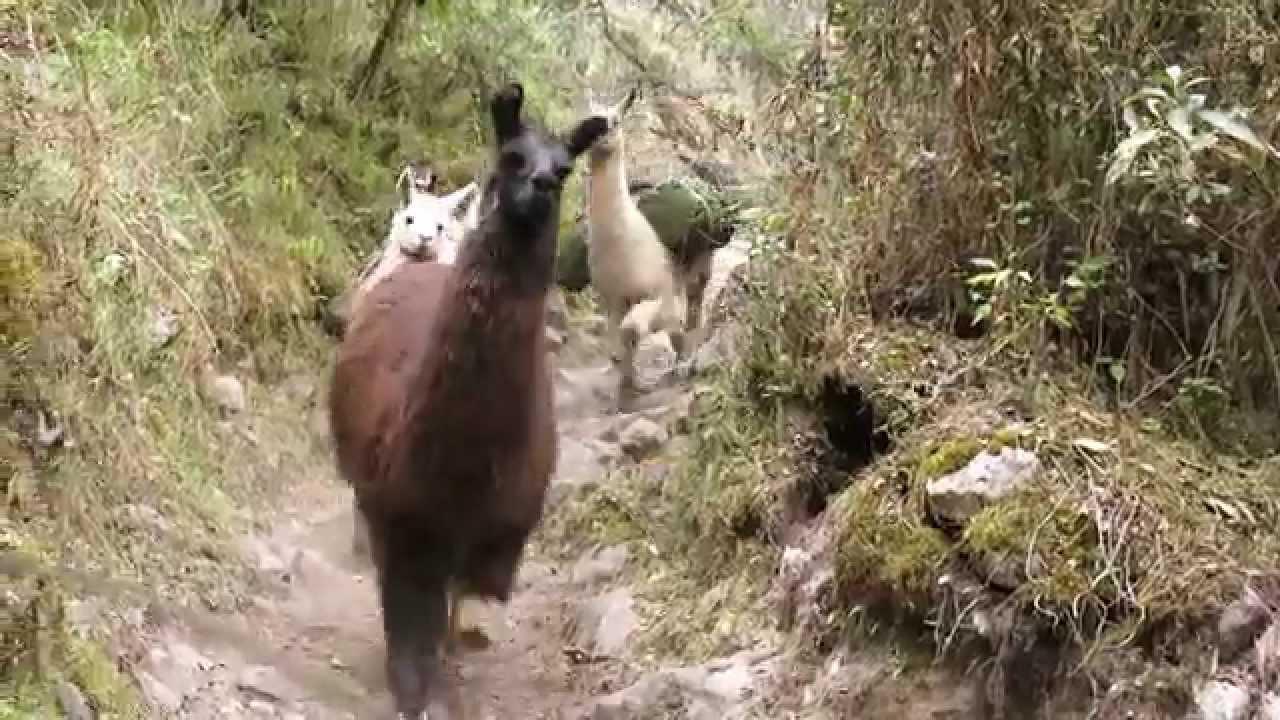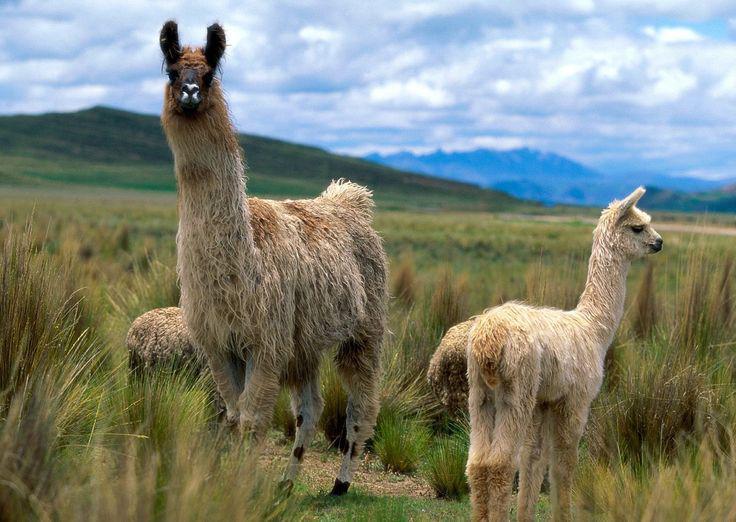The first image is the image on the left, the second image is the image on the right. Assess this claim about the two images: "There is a single alpaca in one image and multiple ones in the other.". Correct or not? Answer yes or no. No. The first image is the image on the left, the second image is the image on the right. Assess this claim about the two images: "The left image features exactly one light-colored llama, and the right image shows a group of at least nine llamas, most of them standing in profile.". Correct or not? Answer yes or no. No. 